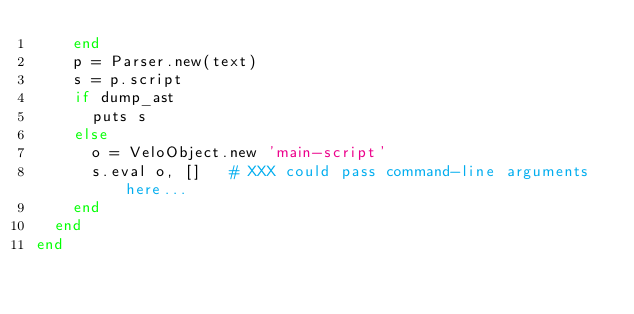Convert code to text. <code><loc_0><loc_0><loc_500><loc_500><_Ruby_>    end
    p = Parser.new(text)
    s = p.script
    if dump_ast
      puts s
    else
      o = VeloObject.new 'main-script'
      s.eval o, []   # XXX could pass command-line arguments here...
    end
  end
end
</code> 